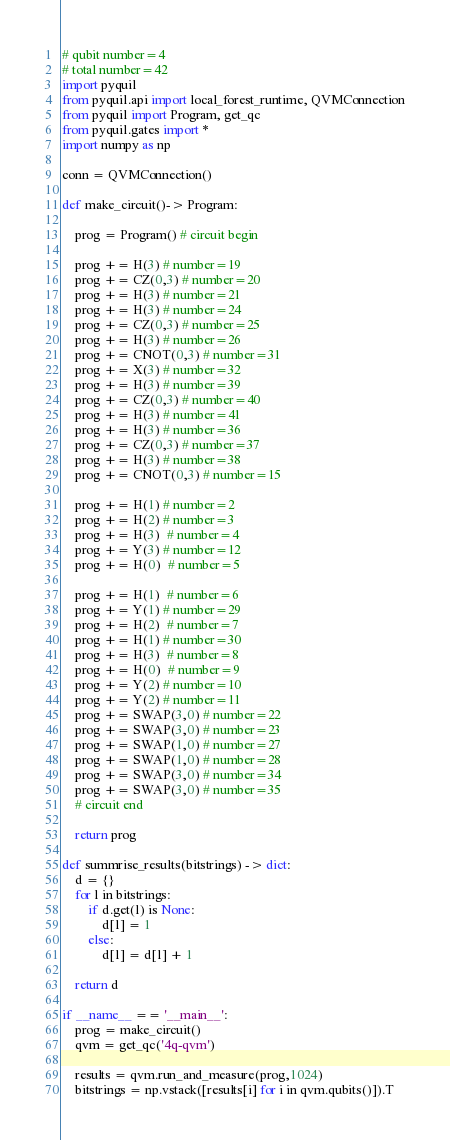Convert code to text. <code><loc_0><loc_0><loc_500><loc_500><_Python_># qubit number=4
# total number=42
import pyquil
from pyquil.api import local_forest_runtime, QVMConnection
from pyquil import Program, get_qc
from pyquil.gates import *
import numpy as np

conn = QVMConnection()

def make_circuit()-> Program:

    prog = Program() # circuit begin

    prog += H(3) # number=19
    prog += CZ(0,3) # number=20
    prog += H(3) # number=21
    prog += H(3) # number=24
    prog += CZ(0,3) # number=25
    prog += H(3) # number=26
    prog += CNOT(0,3) # number=31
    prog += X(3) # number=32
    prog += H(3) # number=39
    prog += CZ(0,3) # number=40
    prog += H(3) # number=41
    prog += H(3) # number=36
    prog += CZ(0,3) # number=37
    prog += H(3) # number=38
    prog += CNOT(0,3) # number=15

    prog += H(1) # number=2
    prog += H(2) # number=3
    prog += H(3)  # number=4
    prog += Y(3) # number=12
    prog += H(0)  # number=5

    prog += H(1)  # number=6
    prog += Y(1) # number=29
    prog += H(2)  # number=7
    prog += H(1) # number=30
    prog += H(3)  # number=8
    prog += H(0)  # number=9
    prog += Y(2) # number=10
    prog += Y(2) # number=11
    prog += SWAP(3,0) # number=22
    prog += SWAP(3,0) # number=23
    prog += SWAP(1,0) # number=27
    prog += SWAP(1,0) # number=28
    prog += SWAP(3,0) # number=34
    prog += SWAP(3,0) # number=35
    # circuit end

    return prog

def summrise_results(bitstrings) -> dict:
    d = {}
    for l in bitstrings:
        if d.get(l) is None:
            d[l] = 1
        else:
            d[l] = d[l] + 1

    return d

if __name__ == '__main__':
    prog = make_circuit()
    qvm = get_qc('4q-qvm')

    results = qvm.run_and_measure(prog,1024)
    bitstrings = np.vstack([results[i] for i in qvm.qubits()]).T</code> 